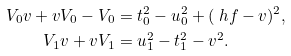Convert formula to latex. <formula><loc_0><loc_0><loc_500><loc_500>V _ { 0 } v + v V _ { 0 } - V _ { 0 } & = t _ { 0 } ^ { 2 } - u _ { 0 } ^ { 2 } + ( \ h f - v ) ^ { 2 } , \\ V _ { 1 } v + v V _ { 1 } & = u _ { 1 } ^ { 2 } - t _ { 1 } ^ { 2 } - v ^ { 2 } .</formula> 